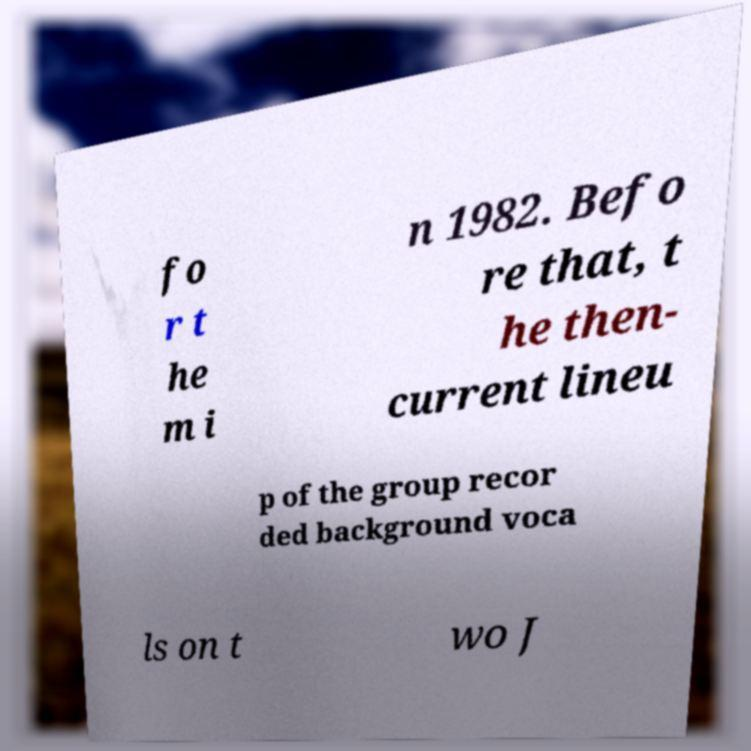Please identify and transcribe the text found in this image. fo r t he m i n 1982. Befo re that, t he then- current lineu p of the group recor ded background voca ls on t wo J 